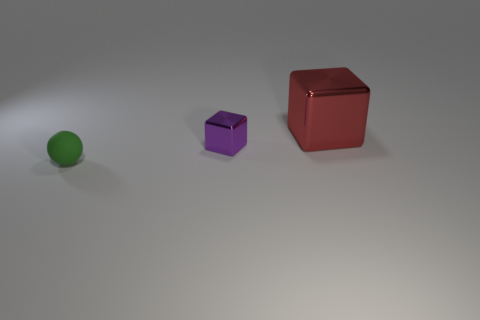If you had to guess the materials the objects are made of, what would you say? Based on their appearances in the image, the green sphere has a matte finish suggestive of a rubber or plastic material. The purple cube has a slight sheen that could indicate a metallic nature. The red cube, given its reflective surface, likely represents a polished metal material. 